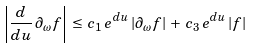Convert formula to latex. <formula><loc_0><loc_0><loc_500><loc_500>\left | \frac { d } { d u } \, \partial _ { \omega } f \right | \, \leq \, c _ { 1 } \, e ^ { d u } \, | \partial _ { \omega } f | \, + \, c _ { 3 } \, e ^ { d u } \, | f |</formula> 